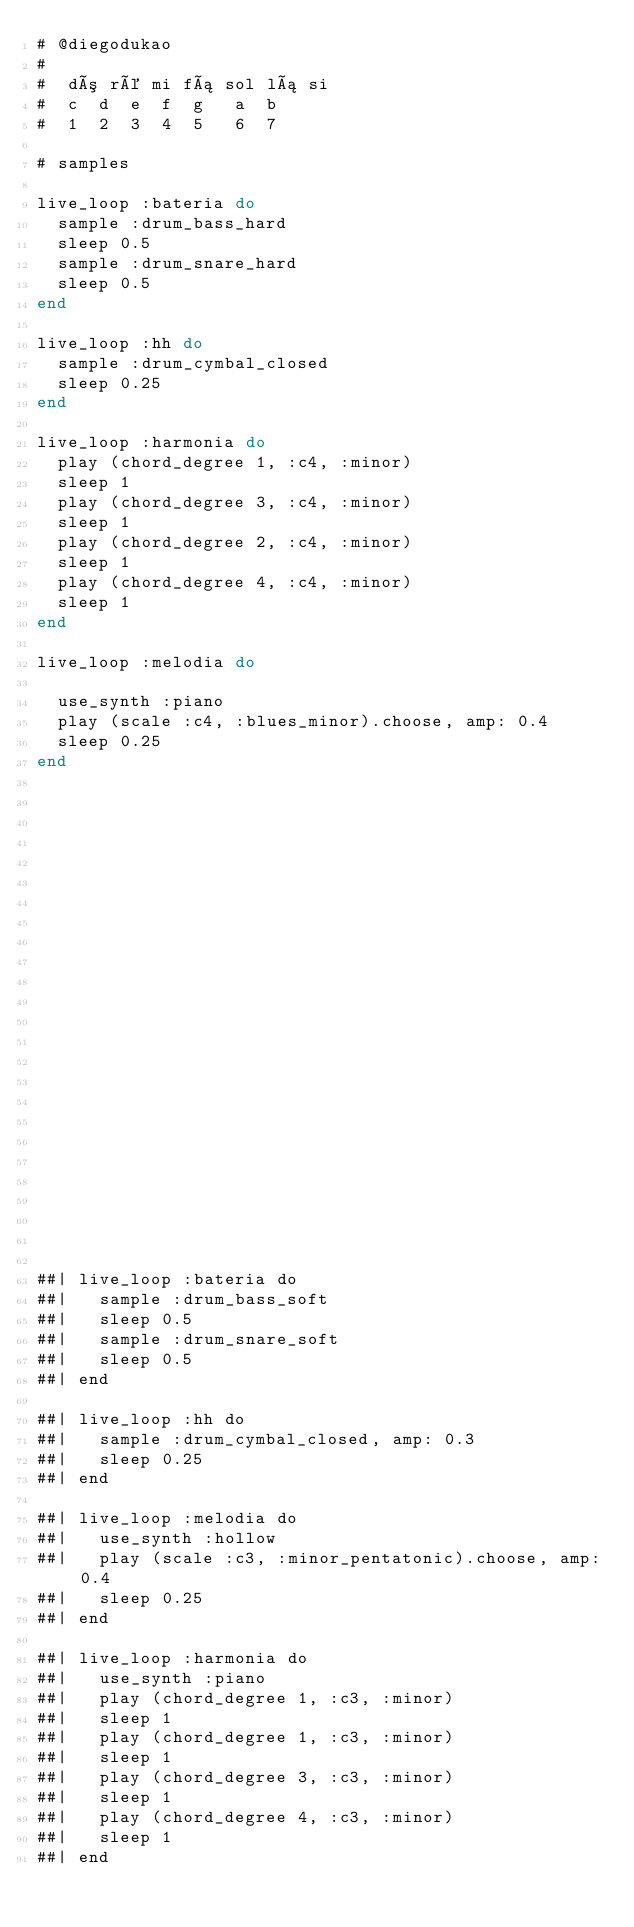Convert code to text. <code><loc_0><loc_0><loc_500><loc_500><_Ruby_># @diegodukao
#
#  dó ré mi fá sol lá si
#  c  d  e  f  g   a  b
#  1  2  3  4  5   6  7

# samples

live_loop :bateria do
  sample :drum_bass_hard
  sleep 0.5
  sample :drum_snare_hard
  sleep 0.5
end

live_loop :hh do
  sample :drum_cymbal_closed
  sleep 0.25
end

live_loop :harmonia do
  play (chord_degree 1, :c4, :minor)
  sleep 1
  play (chord_degree 3, :c4, :minor)
  sleep 1
  play (chord_degree 2, :c4, :minor)
  sleep 1
  play (chord_degree 4, :c4, :minor)
  sleep 1
end

live_loop :melodia do
  
  use_synth :piano
  play (scale :c4, :blues_minor).choose, amp: 0.4
  sleep 0.25
end

























##| live_loop :bateria do
##|   sample :drum_bass_soft
##|   sleep 0.5
##|   sample :drum_snare_soft
##|   sleep 0.5
##| end

##| live_loop :hh do
##|   sample :drum_cymbal_closed, amp: 0.3
##|   sleep 0.25
##| end

##| live_loop :melodia do
##|   use_synth :hollow
##|   play (scale :c3, :minor_pentatonic).choose, amp: 0.4
##|   sleep 0.25
##| end

##| live_loop :harmonia do
##|   use_synth :piano
##|   play (chord_degree 1, :c3, :minor)
##|   sleep 1
##|   play (chord_degree 1, :c3, :minor)
##|   sleep 1
##|   play (chord_degree 3, :c3, :minor)
##|   sleep 1
##|   play (chord_degree 4, :c3, :minor)
##|   sleep 1
##| end</code> 